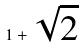<formula> <loc_0><loc_0><loc_500><loc_500>1 + \sqrt { 2 }</formula> 